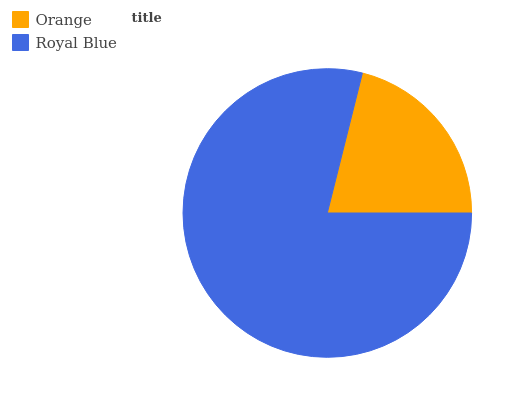Is Orange the minimum?
Answer yes or no. Yes. Is Royal Blue the maximum?
Answer yes or no. Yes. Is Royal Blue the minimum?
Answer yes or no. No. Is Royal Blue greater than Orange?
Answer yes or no. Yes. Is Orange less than Royal Blue?
Answer yes or no. Yes. Is Orange greater than Royal Blue?
Answer yes or no. No. Is Royal Blue less than Orange?
Answer yes or no. No. Is Royal Blue the high median?
Answer yes or no. Yes. Is Orange the low median?
Answer yes or no. Yes. Is Orange the high median?
Answer yes or no. No. Is Royal Blue the low median?
Answer yes or no. No. 